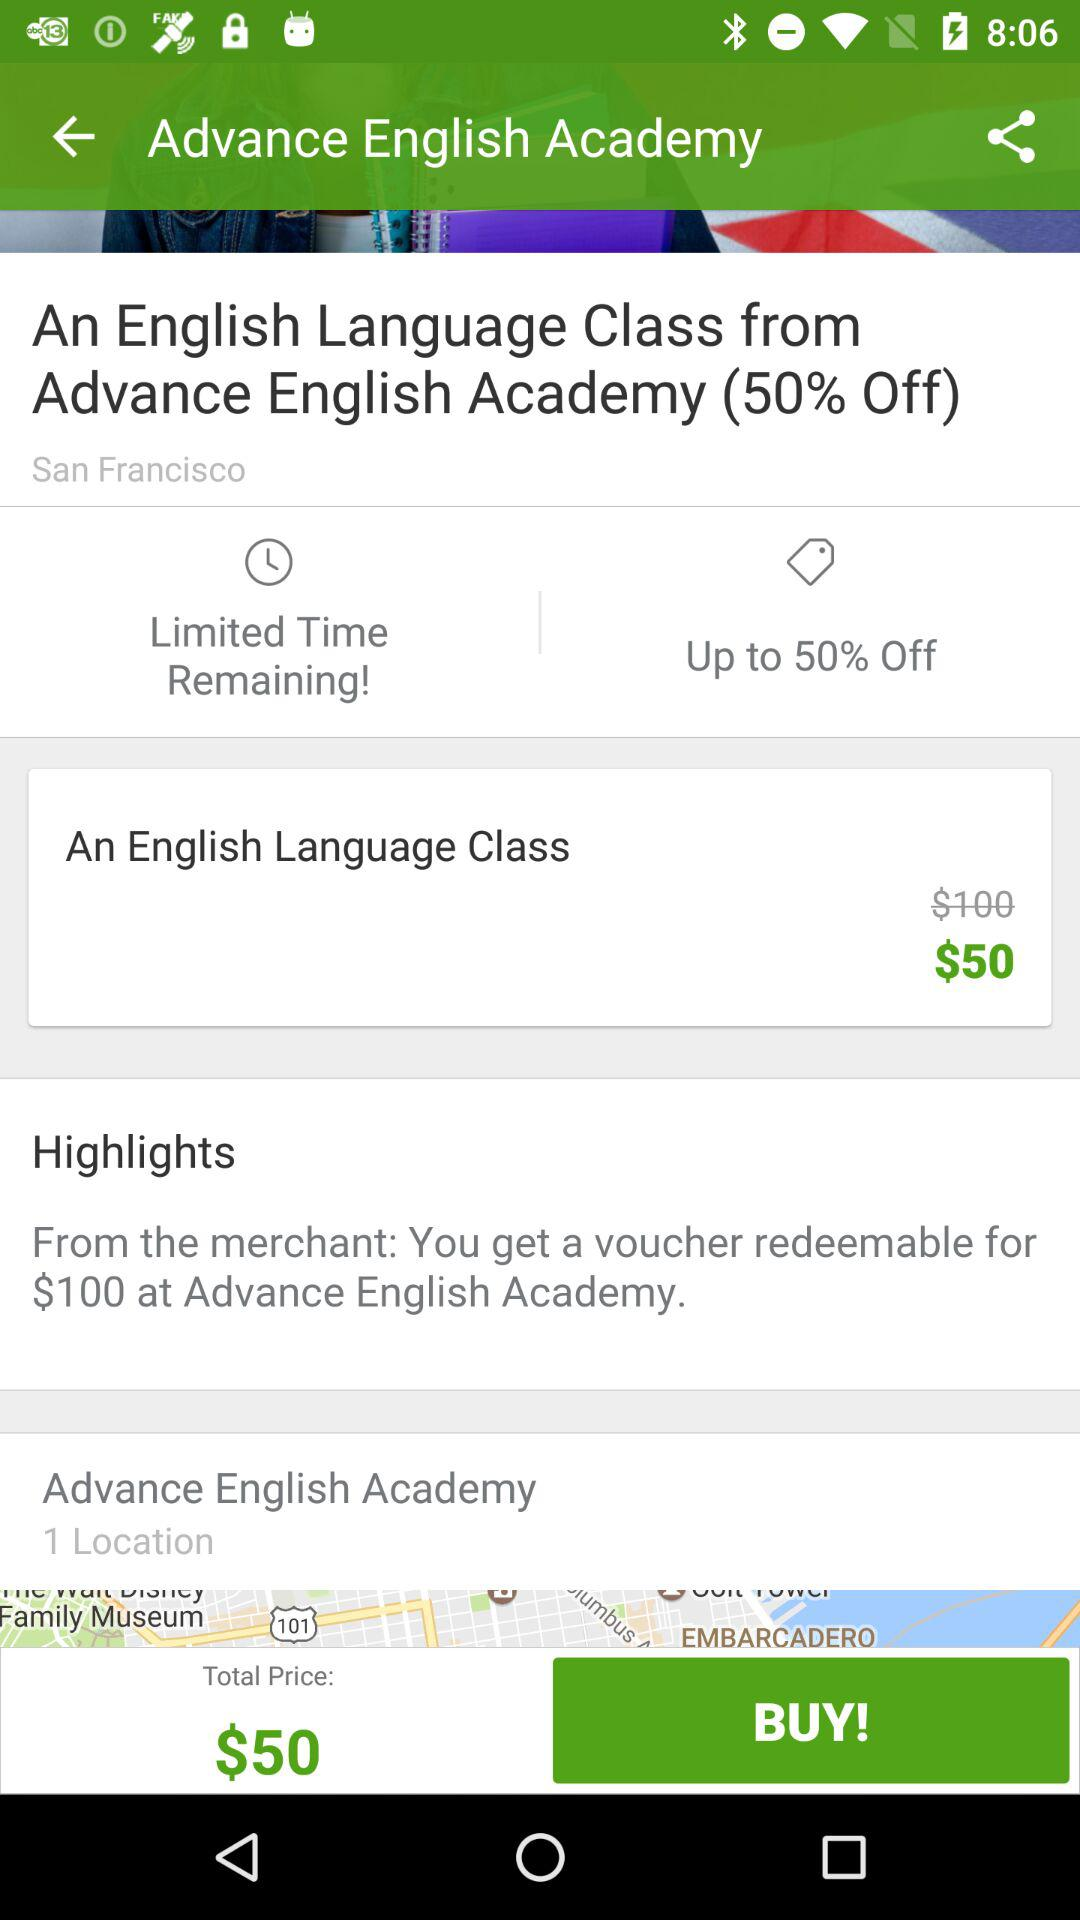What is the current location? The location is Advance English Academy. 